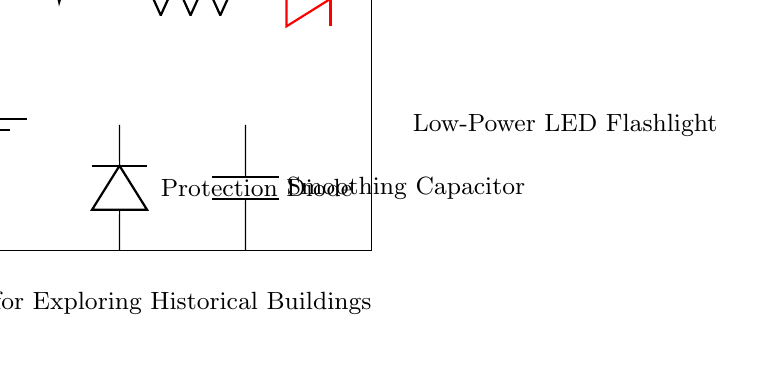What is the voltage of this circuit? The circuit has a voltage source labeled as 3V, which indicates the potential difference provided to power the LED flashlight.
Answer: 3V What type of LED is used in this circuit? The diagram specifies the component as a "red LED," indicating the type of light emitted when powered.
Answer: Red LED What is the resistance value of the resistor? The circuit shows a resistor labeled as 100 ohms, which is the resistance amount that limits current to the LED.
Answer: 100 ohms What is the purpose of the switch in this circuit? The switch allows the user to open or close the circuit, thereby controlling the flow of current to the LED, turning it on or off.
Answer: Control current What is the function of the protection diode? The protection diode allows current to flow in one direction only, safeguarding the circuit from potential reverse polarity that could damage components.
Answer: Prevent damage How does the smoothing capacitor help the LED? The smoothing capacitor stabilizes voltage levels in the circuit, reducing flickering and ensuring consistent brightness by filtering out fluctuations in power supply.
Answer: Stabilizes voltage 